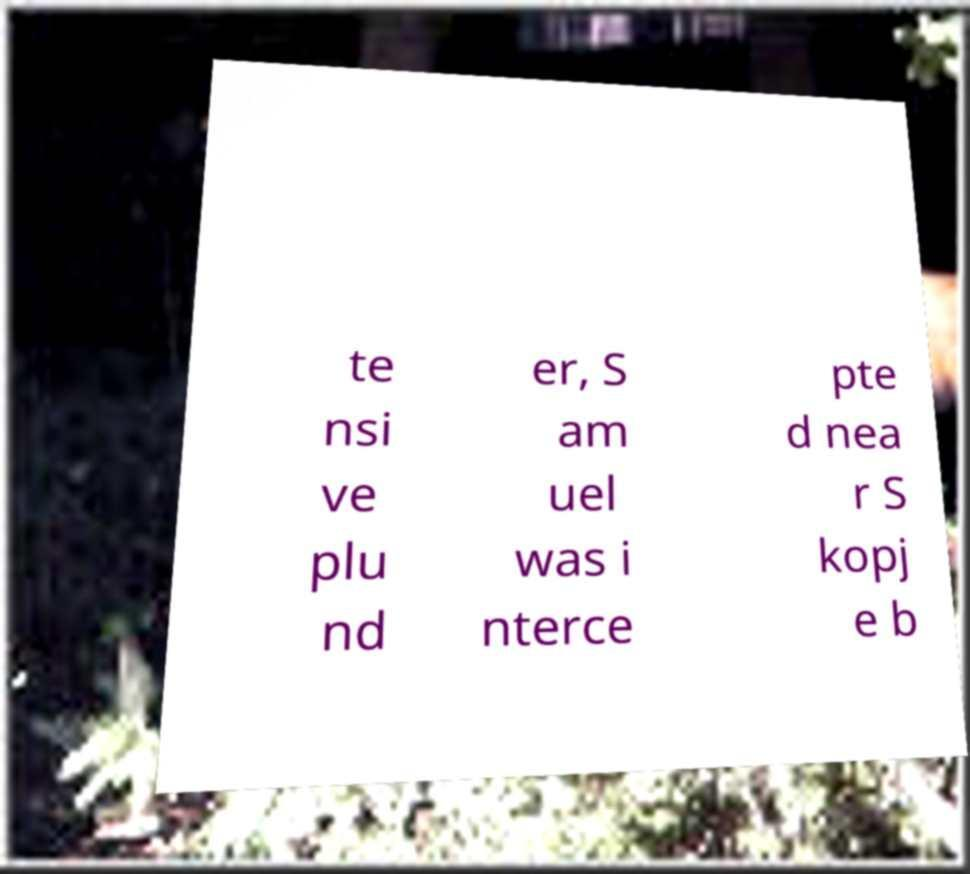Please identify and transcribe the text found in this image. te nsi ve plu nd er, S am uel was i nterce pte d nea r S kopj e b 